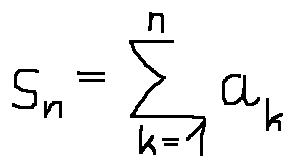<formula> <loc_0><loc_0><loc_500><loc_500>s _ { n } = \sum \lim i t s _ { k = 1 } ^ { n } a _ { k }</formula> 